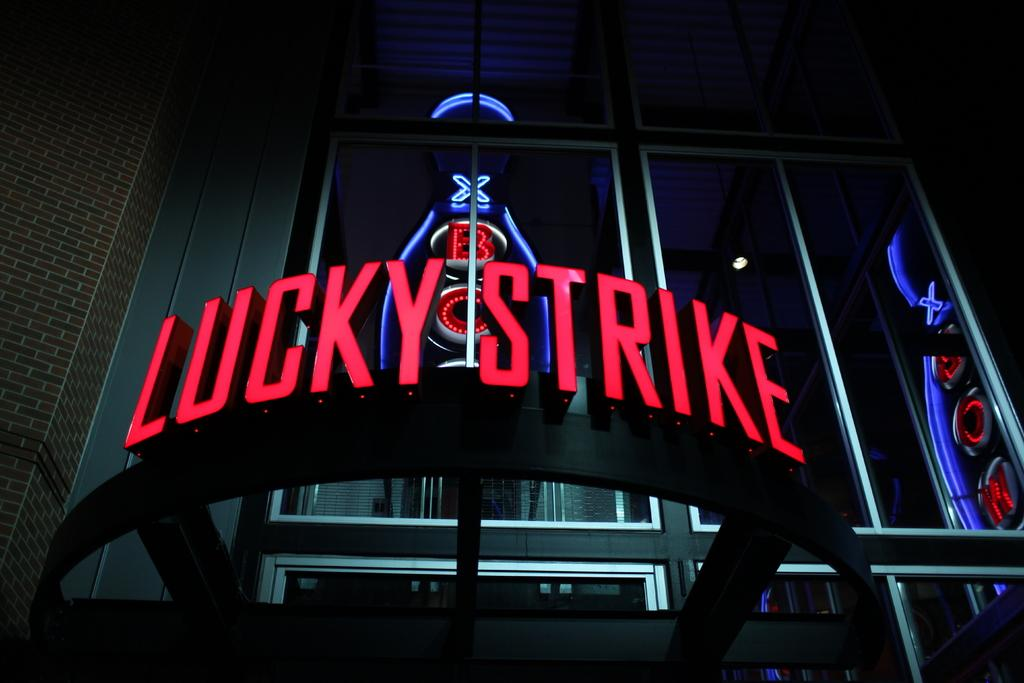What is the main object in the image? There is a name board in the image. What feature of the name board is mentioned? There are lights inside the name board. What can be seen in the background of the image? There is a building and a glass window in the background of the image. What type of haircut is the fish getting in the image? There is no fish or haircut present in the image. 